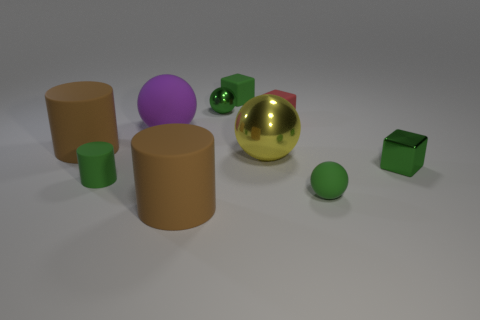Subtract all big matte cylinders. How many cylinders are left? 1 Subtract 1 balls. How many balls are left? 3 Subtract all red spheres. Subtract all yellow cubes. How many spheres are left? 4 Subtract all blocks. How many objects are left? 7 Add 6 green metal cubes. How many green metal cubes are left? 7 Add 4 small red matte cylinders. How many small red matte cylinders exist? 4 Subtract 0 cyan spheres. How many objects are left? 10 Subtract all large rubber objects. Subtract all tiny cyan spheres. How many objects are left? 7 